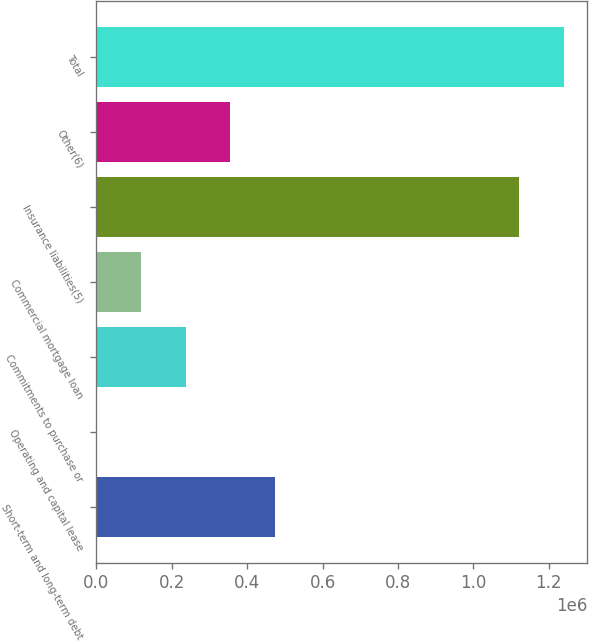<chart> <loc_0><loc_0><loc_500><loc_500><bar_chart><fcel>Short-term and long-term debt<fcel>Operating and capital lease<fcel>Commitments to purchase or<fcel>Commercial mortgage loan<fcel>Insurance liabilities(5)<fcel>Other(6)<fcel>Total<nl><fcel>473185<fcel>665<fcel>236925<fcel>118795<fcel>1.12187e+06<fcel>355055<fcel>1.24e+06<nl></chart> 